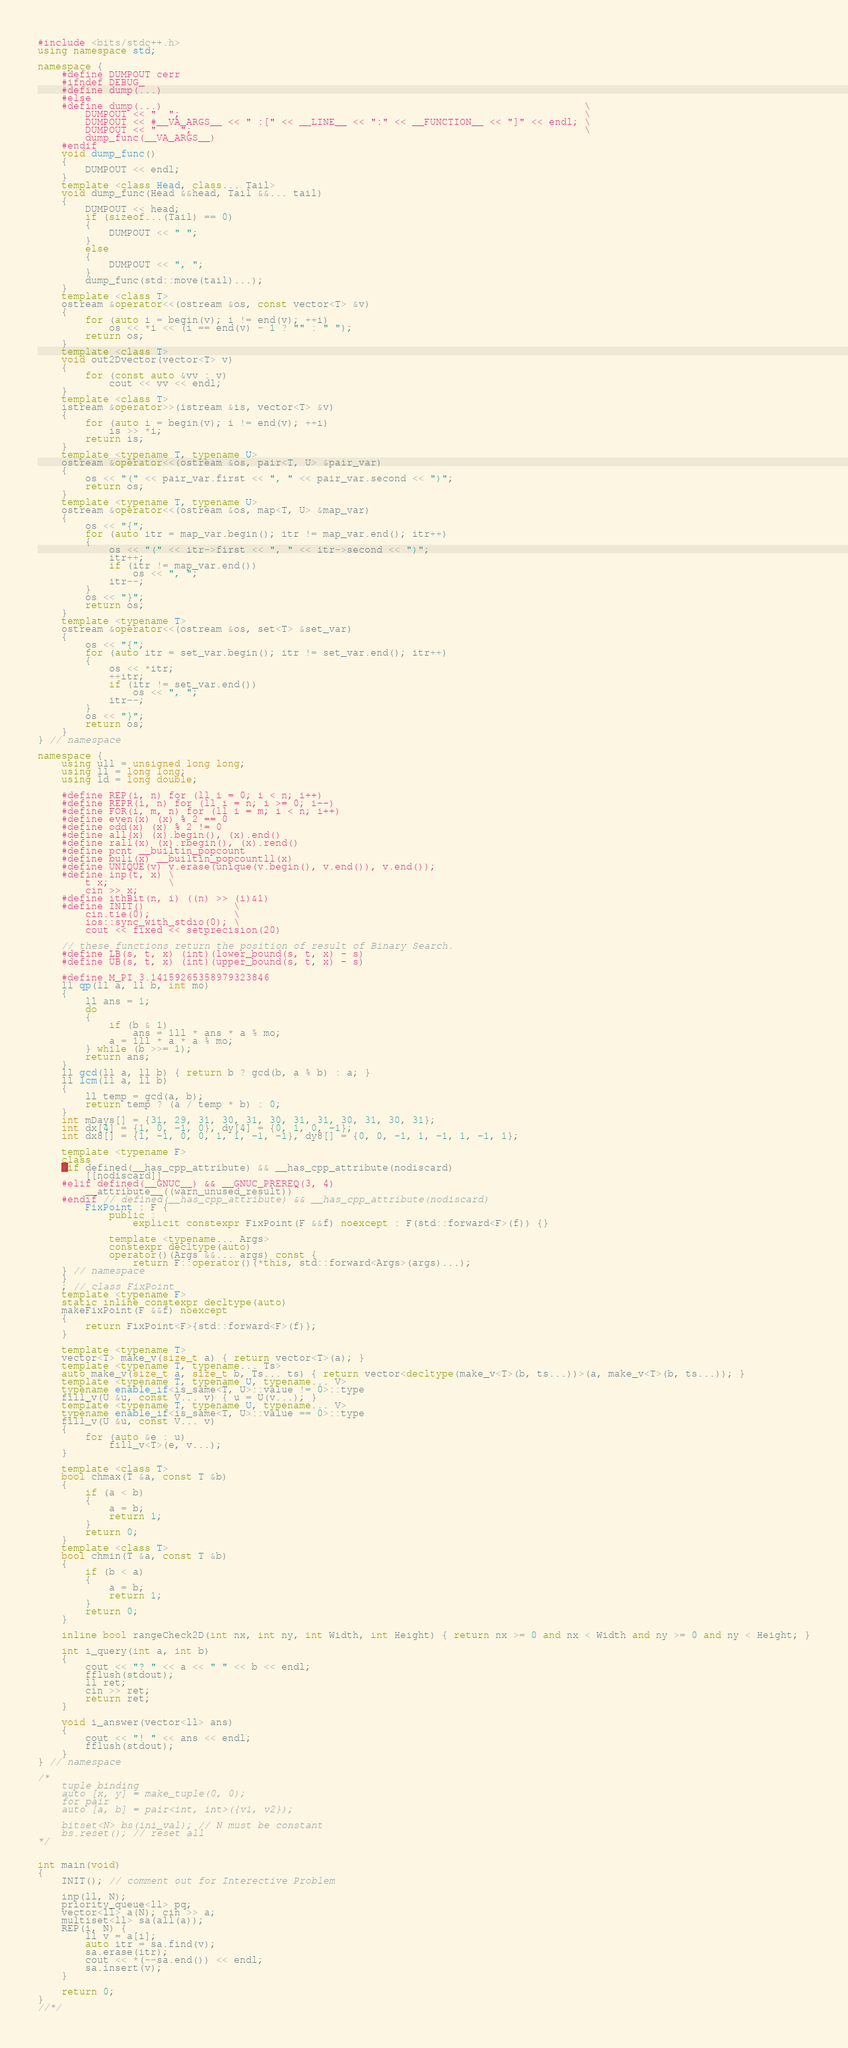Convert code to text. <code><loc_0><loc_0><loc_500><loc_500><_C++_>#include <bits/stdc++.h>
using namespace std;

namespace {
    #define DUMPOUT cerr
    #ifndef DEBUG_
    #define dump(...)
    #else
    #define dump(...)                                                                       \
        DUMPOUT << "  ";                                                                    \
        DUMPOUT << #__VA_ARGS__ << " :[" << __LINE__ << ":" << __FUNCTION__ << "]" << endl; \
        DUMPOUT << "    ";                                                                  \
        dump_func(__VA_ARGS__)
    #endif
    void dump_func()
    {
        DUMPOUT << endl;
    }
    template <class Head, class... Tail>
    void dump_func(Head &&head, Tail &&... tail)
    {
        DUMPOUT << head;
        if (sizeof...(Tail) == 0)
        {
            DUMPOUT << " ";
        }
        else
        {
            DUMPOUT << ", ";
        }
        dump_func(std::move(tail)...);
    }
    template <class T>
    ostream &operator<<(ostream &os, const vector<T> &v)
    {
        for (auto i = begin(v); i != end(v); ++i)
            os << *i << (i == end(v) - 1 ? "" : " ");
        return os;
    }
    template <class T>
    void out2Dvector(vector<T> v)
    {
        for (const auto &vv : v)
            cout << vv << endl;
    }
    template <class T>
    istream &operator>>(istream &is, vector<T> &v)
    {
        for (auto i = begin(v); i != end(v); ++i)
            is >> *i;
        return is;
    }
    template <typename T, typename U>
    ostream &operator<<(ostream &os, pair<T, U> &pair_var)
    {
        os << "(" << pair_var.first << ", " << pair_var.second << ")";
        return os;
    }
    template <typename T, typename U>
    ostream &operator<<(ostream &os, map<T, U> &map_var)
    {
        os << "{";
        for (auto itr = map_var.begin(); itr != map_var.end(); itr++)
        {
            os << "(" << itr->first << ", " << itr->second << ")";
            itr++;
            if (itr != map_var.end())
                os << ", ";
            itr--;
        }
        os << "}";
        return os;
    }
    template <typename T>
    ostream &operator<<(ostream &os, set<T> &set_var)
    {
        os << "{";
        for (auto itr = set_var.begin(); itr != set_var.end(); itr++)
        {
            os << *itr;
            ++itr;
            if (itr != set_var.end())
                os << ", ";
            itr--;
        }
        os << "}";
        return os;
    }
} // namespace

namespace {
    using ull = unsigned long long;
    using ll = long long;
    using ld = long double;

    #define REP(i, n) for (ll i = 0; i < n; i++)
    #define REPR(i, n) for (ll i = n; i >= 0; i--)
    #define FOR(i, m, n) for (ll i = m; i < n; i++)
    #define even(x) (x) % 2 == 0
    #define odd(x) (x) % 2 != 0
    #define all(x) (x).begin(), (x).end()
    #define rall(x) (x).rbegin(), (x).rend()
    #define pcnt __builtin_popcount
    #define buli(x) __builtin_popcountll(x)
    #define UNIQUE(v) v.erase(unique(v.begin(), v.end()), v.end());
    #define inp(t, x) \
        t x;          \
        cin >> x;
    #define ithBit(n, i) ((n) >> (i)&1)
    #define INIT()               \
        cin.tie(0);              \
        ios::sync_with_stdio(0); \
        cout << fixed << setprecision(20)

    // these functions return the position of result of Binary Search.
    #define LB(s, t, x) (int)(lower_bound(s, t, x) - s)
    #define UB(s, t, x) (int)(upper_bound(s, t, x) - s)

    #define M_PI 3.14159265358979323846
    ll qp(ll a, ll b, int mo)
    {
        ll ans = 1;
        do
        {
            if (b & 1)
                ans = 1ll * ans * a % mo;
            a = 1ll * a * a % mo;
        } while (b >>= 1);
        return ans;
    }
    ll gcd(ll a, ll b) { return b ? gcd(b, a % b) : a; }
    ll lcm(ll a, ll b)
    {
        ll temp = gcd(a, b);
        return temp ? (a / temp * b) : 0;
    }
    int mDays[] = {31, 29, 31, 30, 31, 30, 31, 31, 30, 31, 30, 31};
    int dx[4] = {1, 0, -1, 0}, dy[4] = {0, 1, 0, -1};
    int dx8[] = {1, -1, 0, 0, 1, 1, -1, -1}, dy8[] = {0, 0, -1, 1, -1, 1, -1, 1};

    template <typename F>
    class
    #if defined(__has_cpp_attribute) && __has_cpp_attribute(nodiscard)
        [[nodiscard]]
    #elif defined(__GNUC__) && __GNUC_PREREQ(3, 4)
        __attribute__((warn_unused_result))
    #endif // defined(__has_cpp_attribute) && __has_cpp_attribute(nodiscard)
        FixPoint : F {
            public :
                explicit constexpr FixPoint(F &&f) noexcept : F(std::forward<F>(f)) {}

            template <typename... Args>
            constexpr decltype(auto)
            operator()(Args &&... args) const {
                return F::operator()(*this, std::forward<Args>(args)...);
    } // namespace
    }
    ; // class FixPoint
    template <typename F>
    static inline constexpr decltype(auto)
    makeFixPoint(F &&f) noexcept
    {
        return FixPoint<F>{std::forward<F>(f)};
    }

    template <typename T>
    vector<T> make_v(size_t a) { return vector<T>(a); }
    template <typename T, typename... Ts>
    auto make_v(size_t a, size_t b, Ts... ts) { return vector<decltype(make_v<T>(b, ts...))>(a, make_v<T>(b, ts...)); }
    template <typename T, typename U, typename... V>
    typename enable_if<is_same<T, U>::value != 0>::type
    fill_v(U &u, const V... v) { u = U(v...); }
    template <typename T, typename U, typename... V>
    typename enable_if<is_same<T, U>::value == 0>::type
    fill_v(U &u, const V... v)
    {
        for (auto &e : u)
            fill_v<T>(e, v...);
    }

    template <class T>
    bool chmax(T &a, const T &b)
    {
        if (a < b)
        {
            a = b;
            return 1;
        }
        return 0;
    }
    template <class T>
    bool chmin(T &a, const T &b)
    {
        if (b < a)
        {
            a = b;
            return 1;
        }
        return 0;
    }

    inline bool rangeCheck2D(int nx, int ny, int Width, int Height) { return nx >= 0 and nx < Width and ny >= 0 and ny < Height; }

    int i_query(int a, int b)
    {
        cout << "? " << a << " " << b << endl;
        fflush(stdout);
        ll ret;
        cin >> ret;
        return ret;
    }

    void i_answer(vector<ll> ans)
    {
        cout << "! " << ans << endl;
        fflush(stdout);
    }
} // namespace

/*
    tuple binding
    auto [x, y] = make_tuple(0, 0);
    for pair
    auto [a, b] = pair<int, int>({v1, v2});

    bitset<N> bs(ini_val); // N must be constant
    bs.reset(); // reset all
*/


int main(void)
{
    INIT(); // comment out for Interective Problem
    
    inp(ll, N);
    priority_queue<ll> pq;
    vector<ll> a(N); cin >> a;
    multiset<ll> sa(all(a));
    REP(i, N) {
        ll v = a[i];
        auto itr = sa.find(v);
        sa.erase(itr);
        cout << *(--sa.end()) << endl;
        sa.insert(v);
    }

    return 0;
}
//*/</code> 